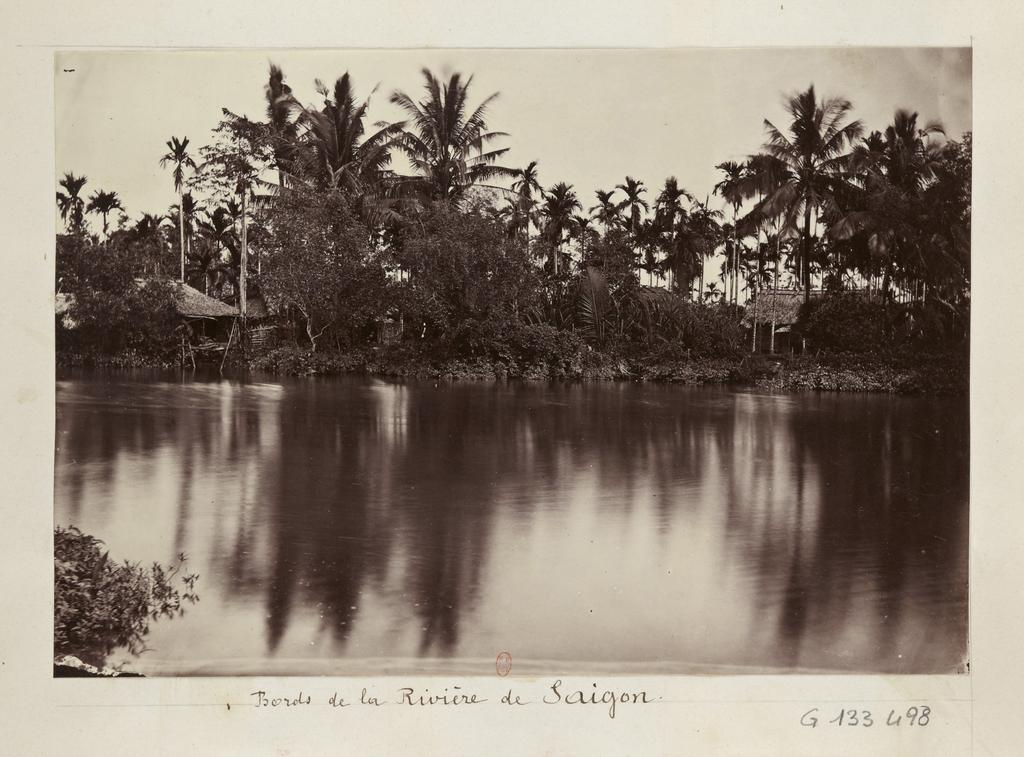What body of water is present in the image? There is a lake in the image. Are there any structures near the lake? Yes, there are houses beside the lake. What type of vegetation can be seen in the image? There are trees in the image. What shape is the glass of water on the table in the image? There is no glass of water present in the image; it only features a lake, houses, and trees. 